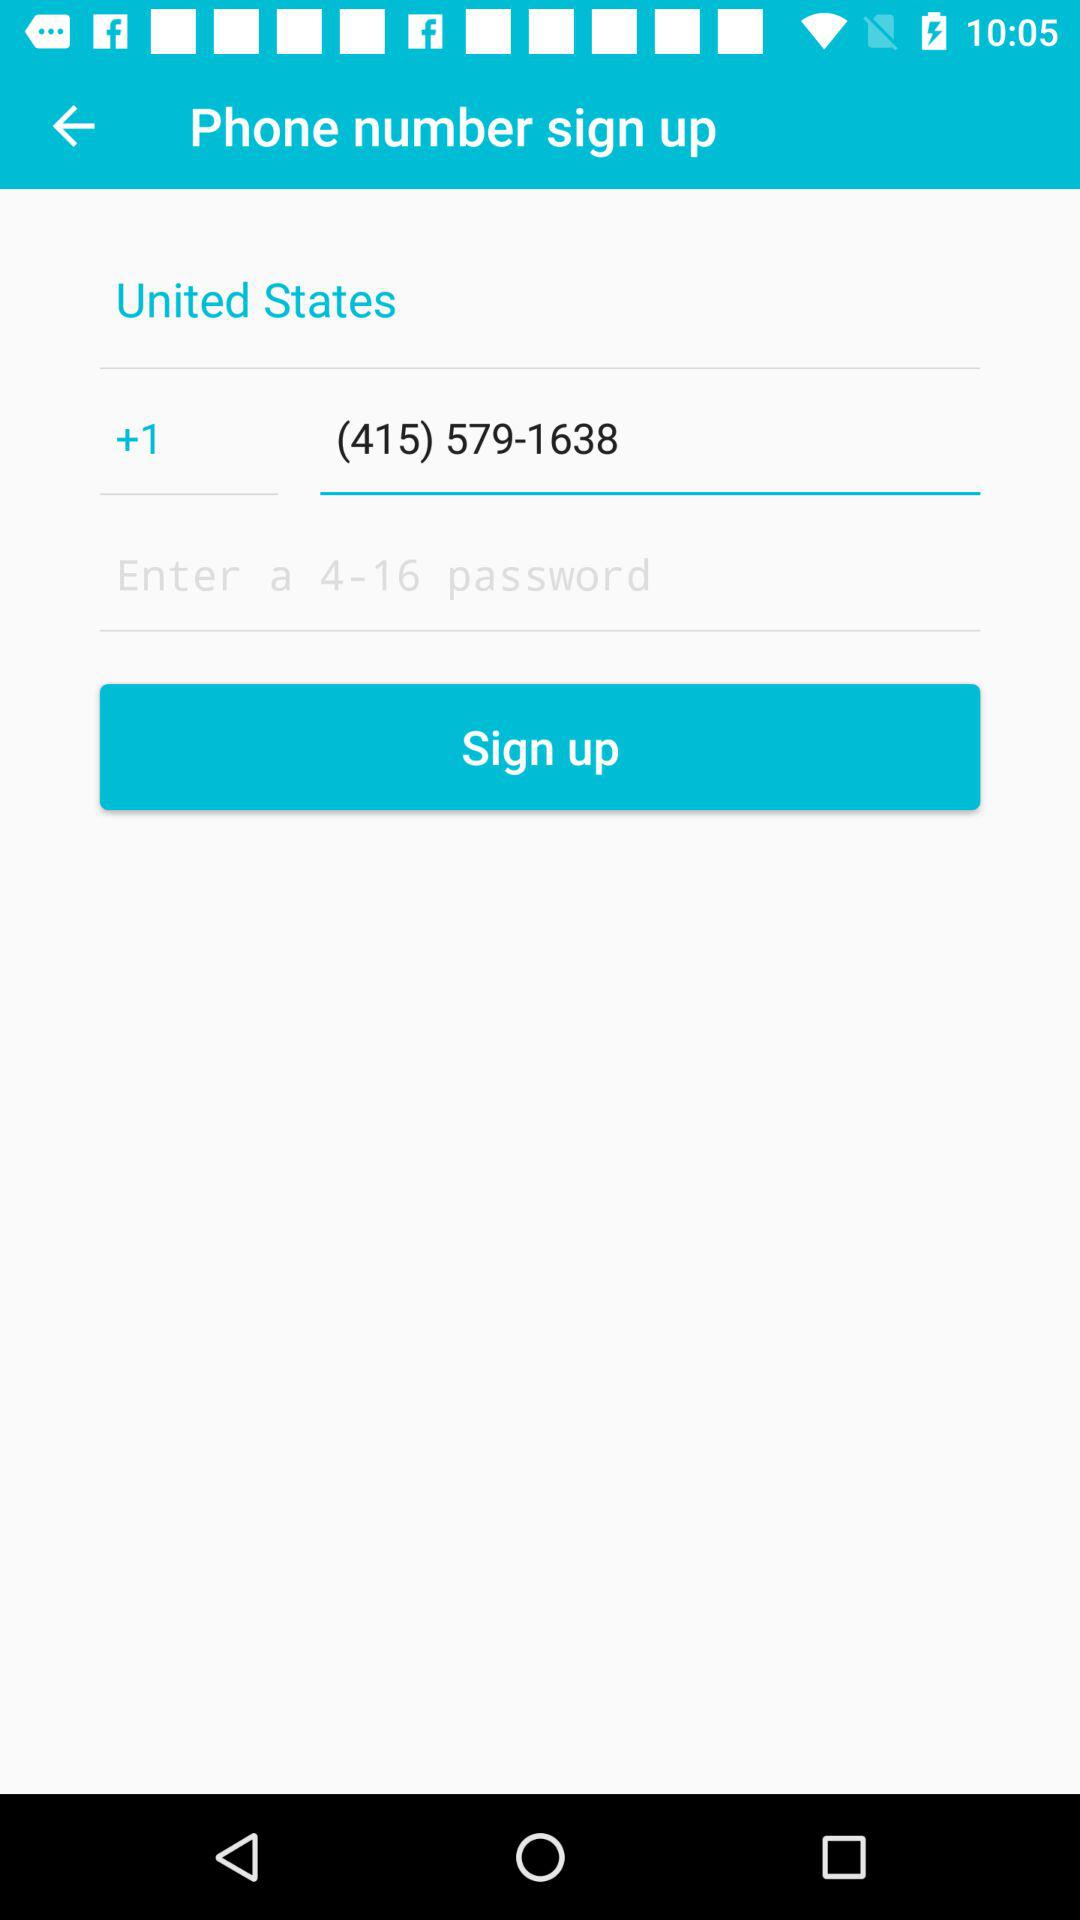What is the number in the search box? The number is (415) 579-1638. 